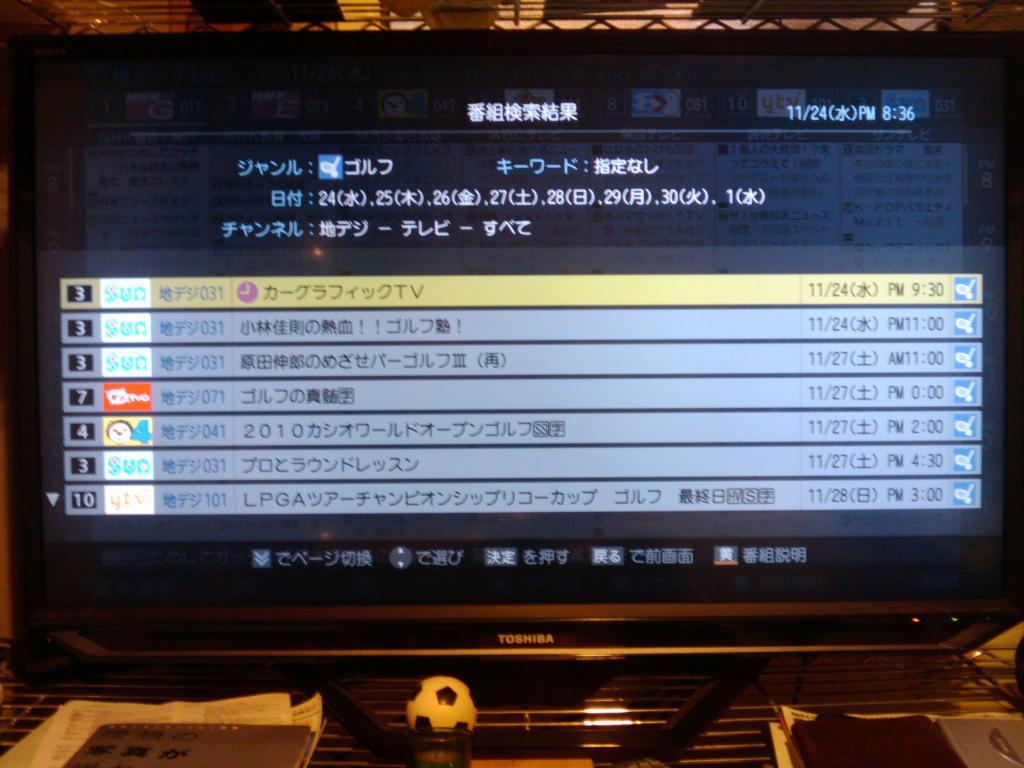<image>
Provide a brief description of the given image. A Toshiba monitor that is covered in foreign text. 